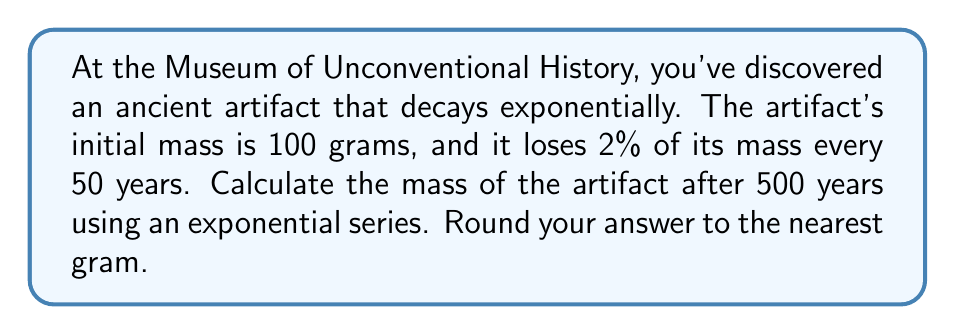Give your solution to this math problem. Let's approach this step-by-step:

1) The exponential decay formula is:
   $$A(t) = A_0 \cdot (1-r)^{t/p}$$
   where:
   $A(t)$ is the amount at time $t$
   $A_0$ is the initial amount
   $r$ is the decay rate per period
   $p$ is the length of each period
   $t$ is the total time

2) Given:
   $A_0 = 100$ grams
   $r = 0.02$ (2%)
   $p = 50$ years
   $t = 500$ years

3) Substituting into the formula:
   $$A(500) = 100 \cdot (1-0.02)^{500/50}$$

4) Simplify the exponent:
   $$A(500) = 100 \cdot (0.98)^{10}$$

5) Calculate:
   $$A(500) = 100 \cdot 0.817073...$$
   $$A(500) = 81.7073...$$

6) Rounding to the nearest gram:
   $$A(500) \approx 82 \text{ grams}$$
Answer: 82 grams 